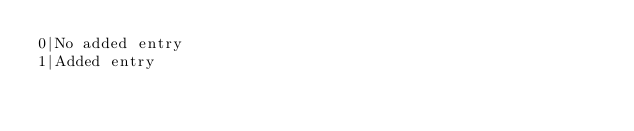<code> <loc_0><loc_0><loc_500><loc_500><_SQL_>0|No added entry
1|Added entry
</code> 